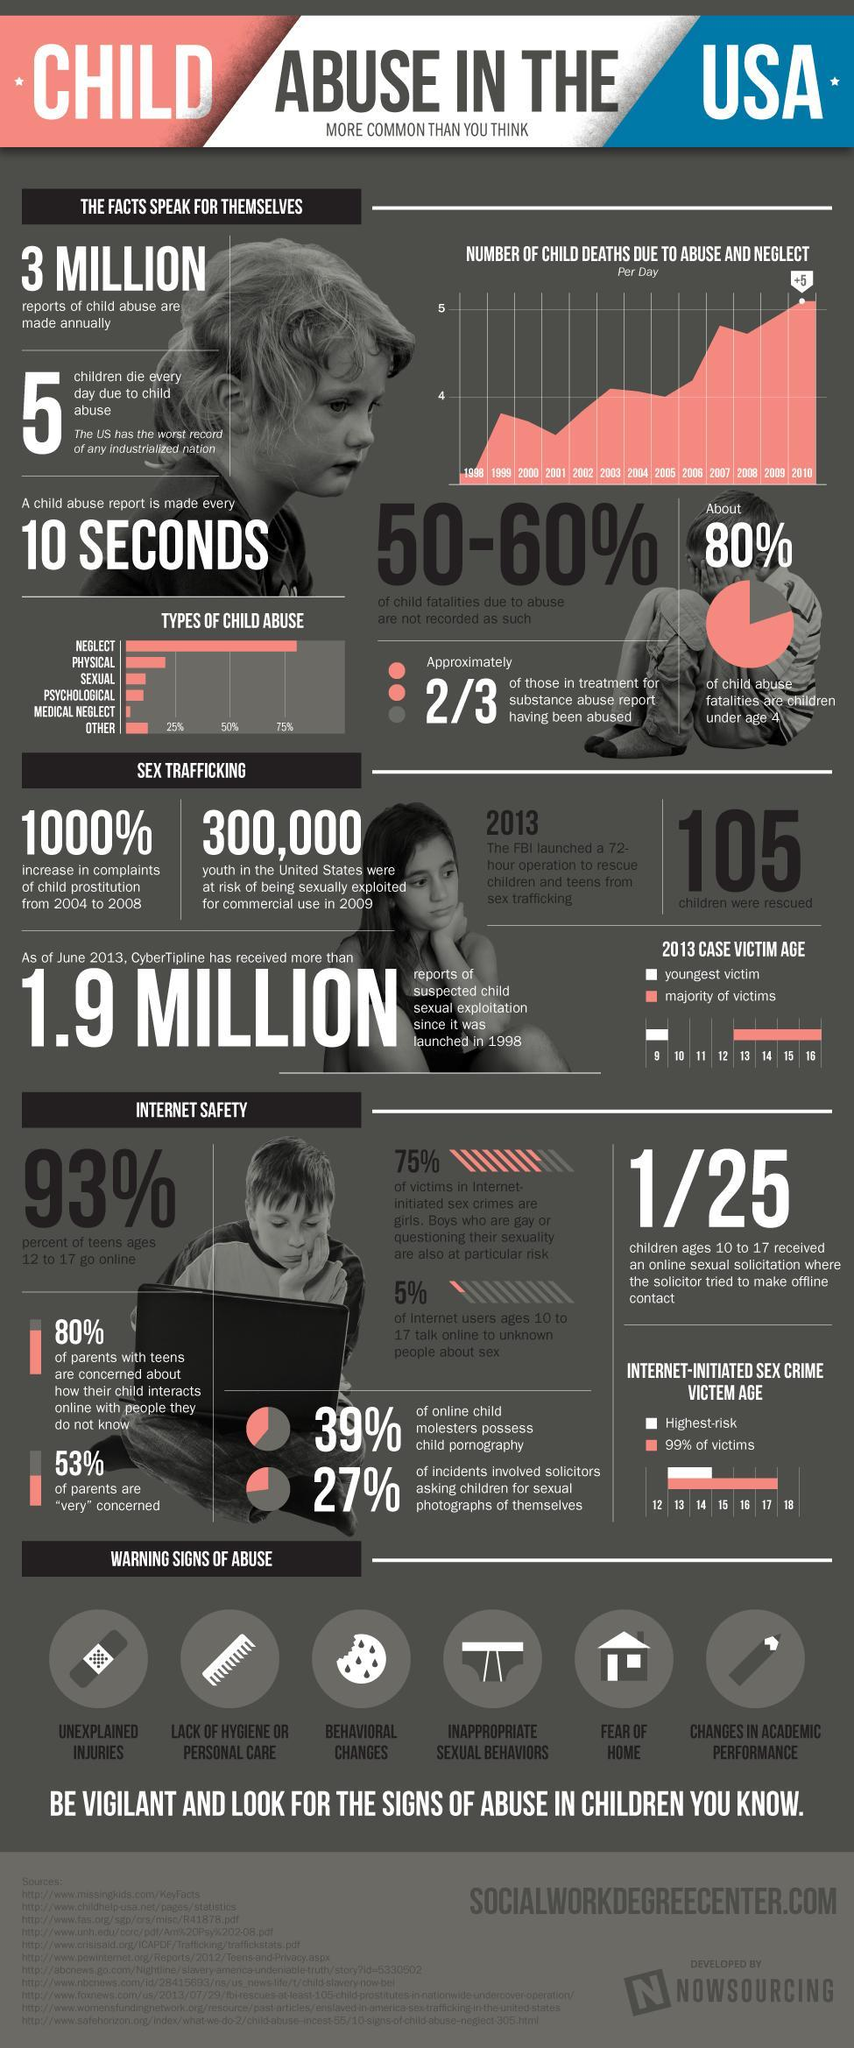What percentage of child abuse fatalities in the U.S. are children under age 4?
Answer the question with a short phrase. 80% What is the percentage increase of child prostitution in USA from 2004 to 2008? 1000% What population of youth in the United States were at risk of being sexually exploited for commercial use in 2009? 300,000 What is the youngest victim age of sexual exploitation in USA in 2013? 9 How many children were rescued from sex trafficking by a 72 hour operation launched by FBI? 105 What percentage of teens in the age group of 12-17 do not go online in the U.S.? 7% Which age group in children are at highest risk of internet initiated sex crime in USA - Age 14-16, Age 13-14, Age 15-18, Age 13-18? Age 13-14 In which year, the number of child deaths due to abuse and neglect is more than 5 per day in the U.S.? 2010 